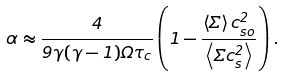<formula> <loc_0><loc_0><loc_500><loc_500>\alpha \approx \frac { 4 } { 9 \gamma ( \gamma - 1 ) \Omega \tau _ { c } } \left ( 1 - \frac { \left < \Sigma \right > c _ { s o } ^ { 2 } } { \left < \Sigma c _ { s } ^ { 2 } \right > } \right ) .</formula> 